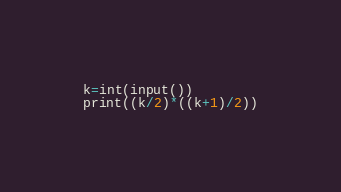<code> <loc_0><loc_0><loc_500><loc_500><_Python_>k=int(input())
print((k/2)*((k+1)/2))</code> 